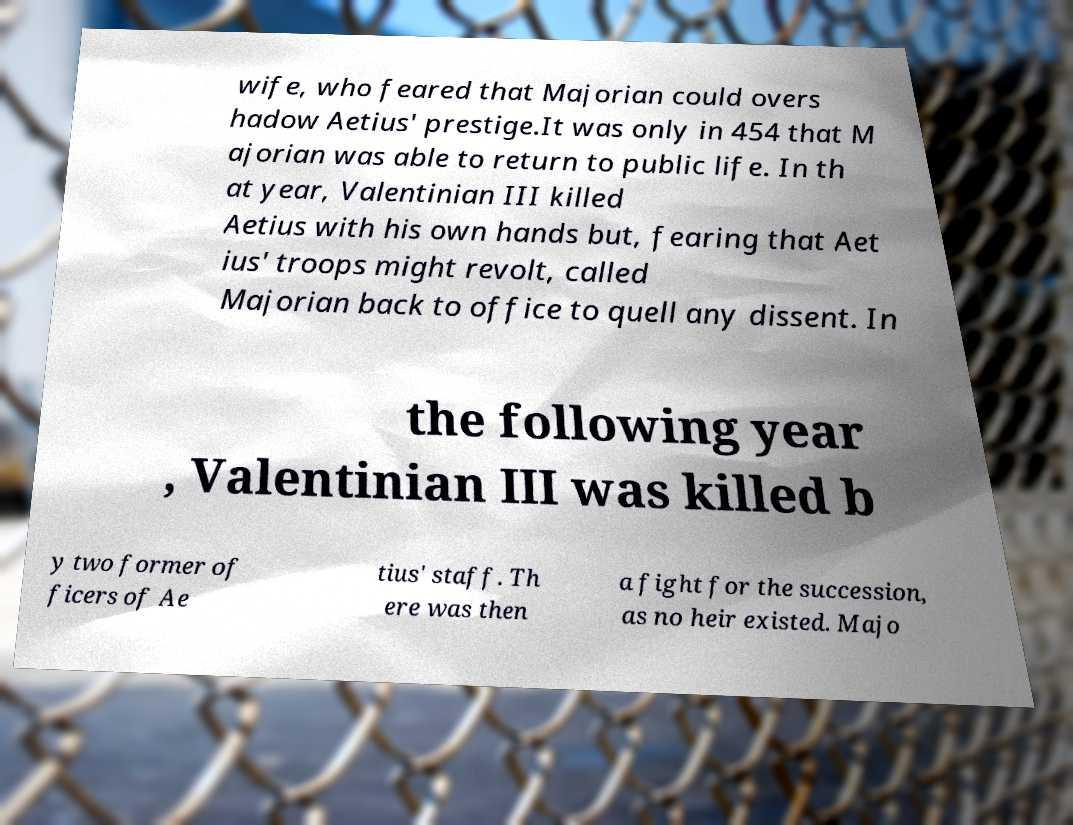There's text embedded in this image that I need extracted. Can you transcribe it verbatim? wife, who feared that Majorian could overs hadow Aetius' prestige.It was only in 454 that M ajorian was able to return to public life. In th at year, Valentinian III killed Aetius with his own hands but, fearing that Aet ius' troops might revolt, called Majorian back to office to quell any dissent. In the following year , Valentinian III was killed b y two former of ficers of Ae tius' staff. Th ere was then a fight for the succession, as no heir existed. Majo 